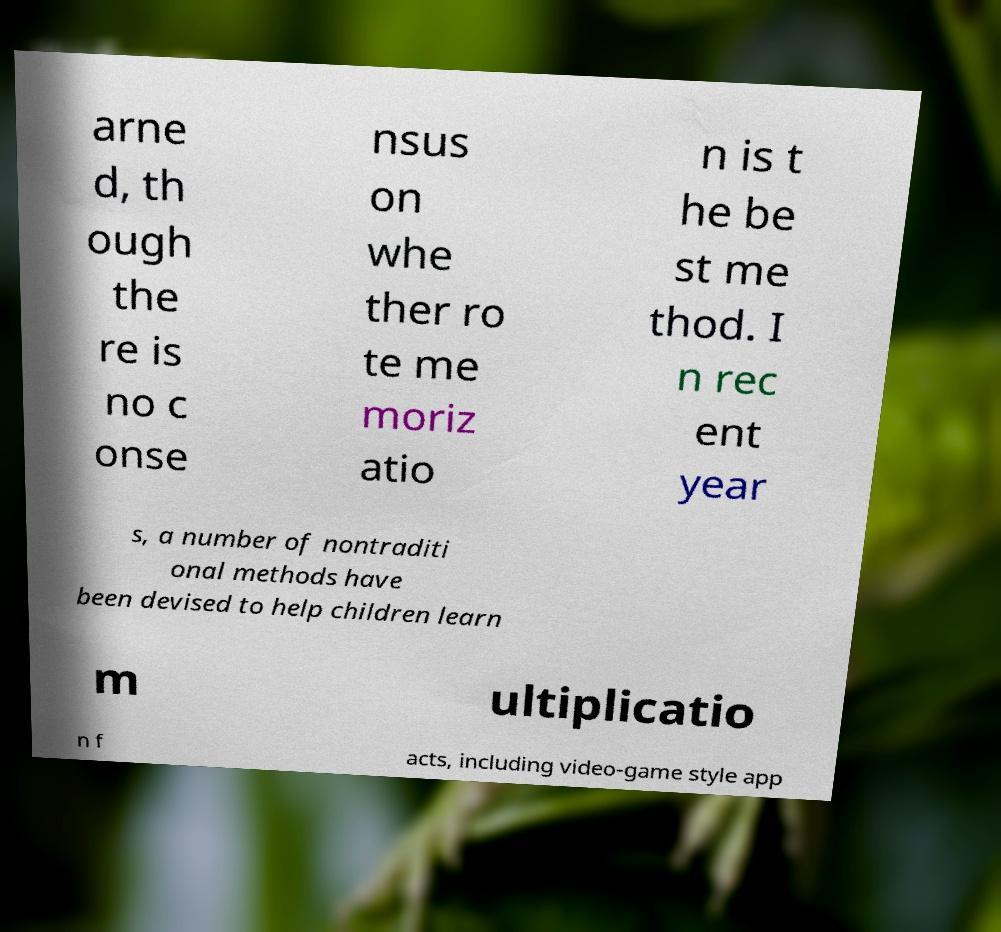Please read and relay the text visible in this image. What does it say? arne d, th ough the re is no c onse nsus on whe ther ro te me moriz atio n is t he be st me thod. I n rec ent year s, a number of nontraditi onal methods have been devised to help children learn m ultiplicatio n f acts, including video-game style app 